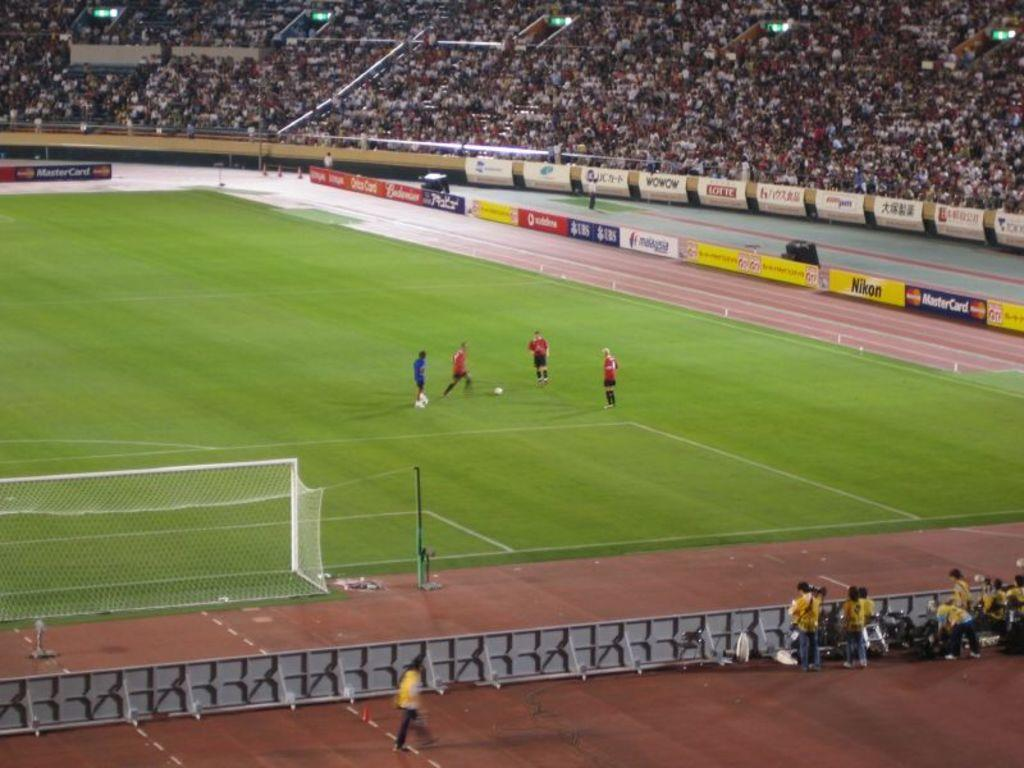What is happening on the ground in the image? There are people on the ground in the image. What is the purpose of the net visible in the image? The net may be used for a game or sporting activity. Can you describe the objects in the image? The objects in the image could be sports equipment or other items related to the activity taking place. What can be seen in the background of the image? There are advertisement boards and a group of people in the background of the image. What type of note is being passed between the people in the image? There is no note being passed between the people in the image; they are engaged in an activity involving a net. 